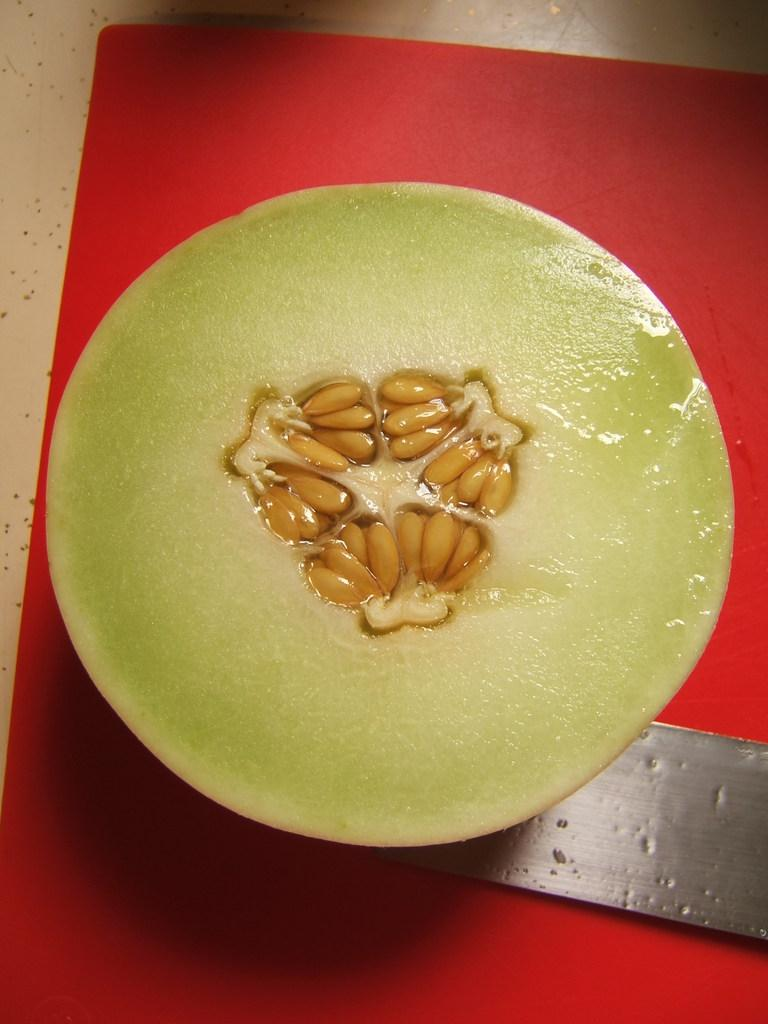What is in the bowl that is visible in the image? There is food in a bowl in the image. What utensil is located at the bottom of the image? There is a knife at the bottom of the image. What surface is visible in the image that might be used for cutting or preparing food? There is a chopping board in the image. What type of rhythm can be heard coming from the goldfish in the image? There are no goldfish present in the image, so it is not possible to determine if they are making any rhythmic sounds. 